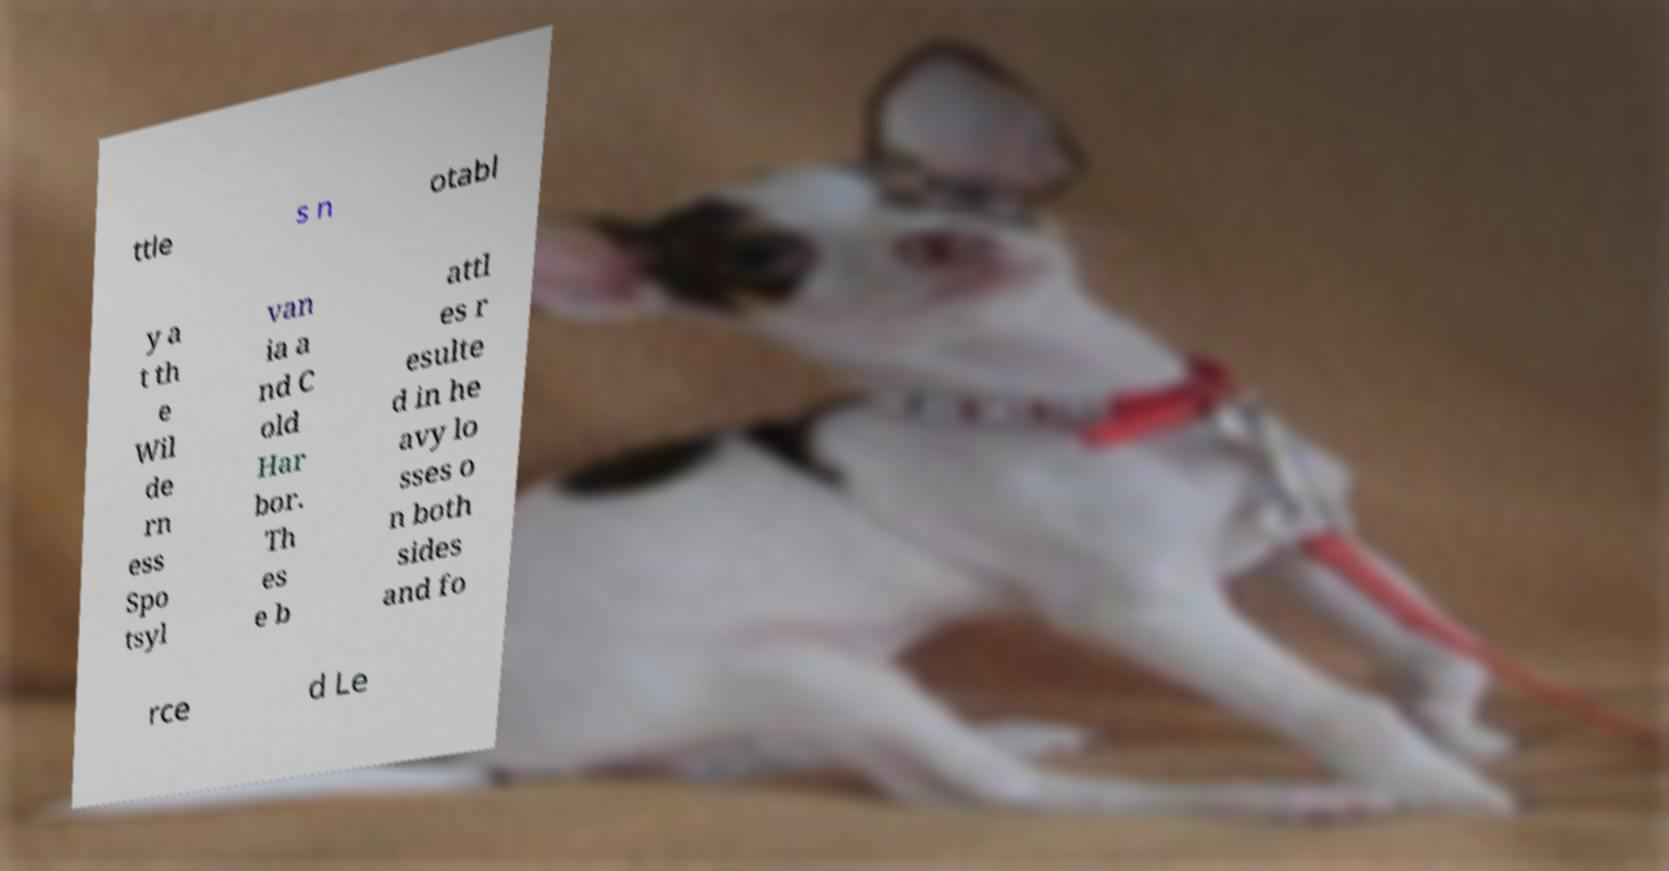Can you accurately transcribe the text from the provided image for me? ttle s n otabl y a t th e Wil de rn ess Spo tsyl van ia a nd C old Har bor. Th es e b attl es r esulte d in he avy lo sses o n both sides and fo rce d Le 